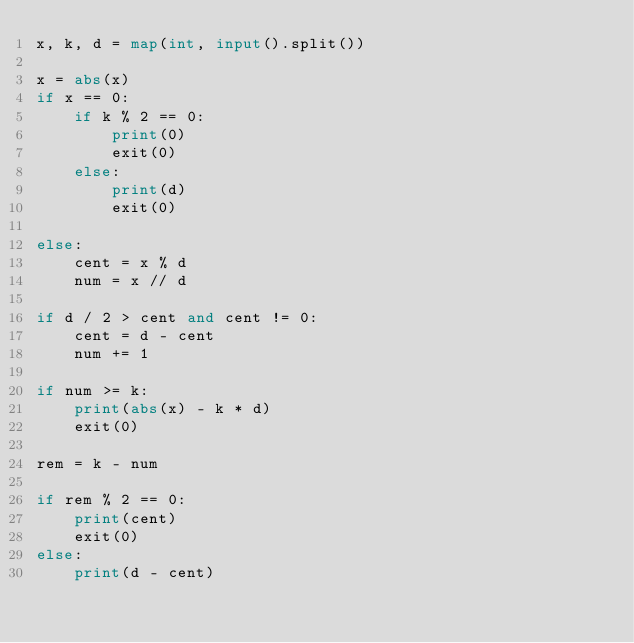Convert code to text. <code><loc_0><loc_0><loc_500><loc_500><_Python_>x, k, d = map(int, input().split())

x = abs(x)
if x == 0:
    if k % 2 == 0:
        print(0)
        exit(0)
    else:
        print(d)
        exit(0)

else:
    cent = x % d
    num = x // d

if d / 2 > cent and cent != 0:
    cent = d - cent
    num += 1

if num >= k:
    print(abs(x) - k * d)
    exit(0)

rem = k - num

if rem % 2 == 0:
    print(cent)
    exit(0)
else:
    print(d - cent)</code> 